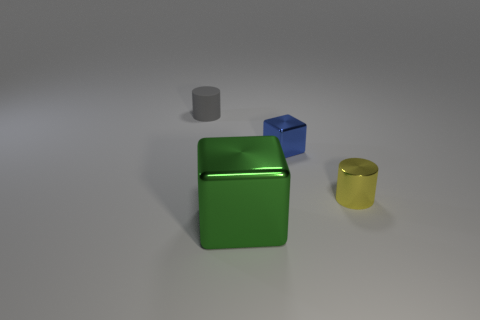How does the arrangement of objects influence our perception of the image? The arrangement of the objects with ample space between them allows each to be individually appreciated for its shape and color. The size contrast between the large green cube and the smaller objects adds depth to the image and could imply a sense of scale or importance. 